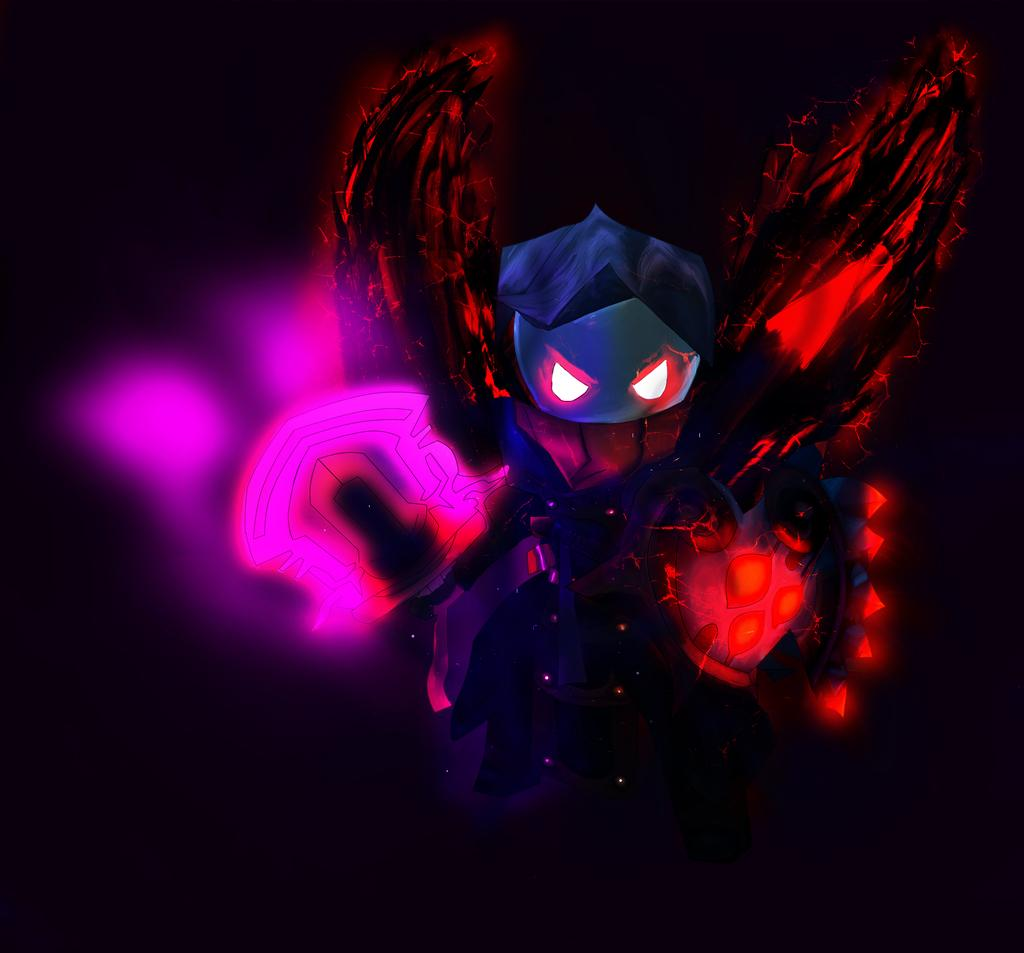What type of image is being described? The image is an edited picture. What can be seen in the image besides the edited background? There is a toy in the image. What color is the background of the image? The background of the image is black. What type of substance is dripping from the icicle in the image? There is no icicle present in the image, so it is not possible to answer that question. 